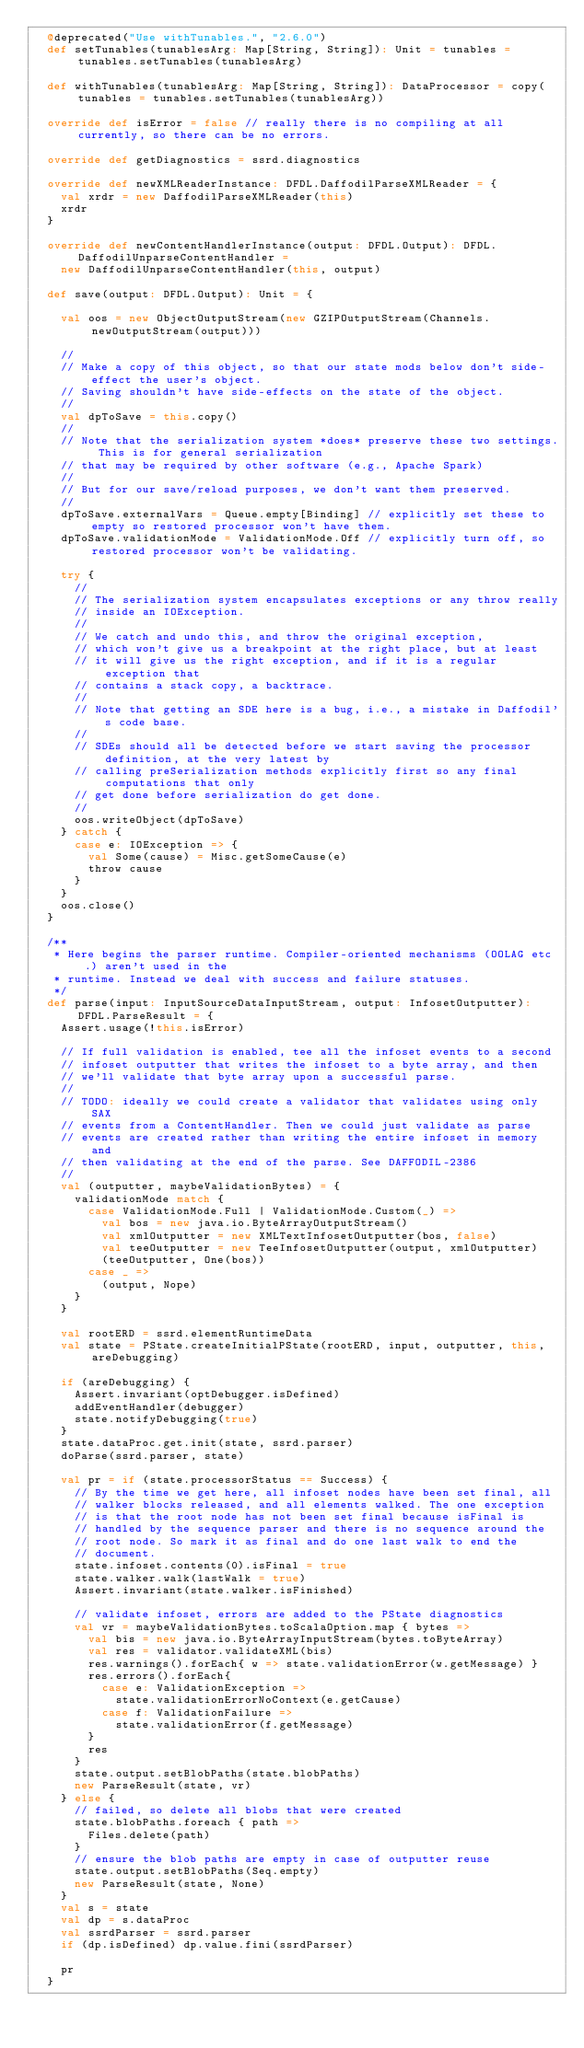Convert code to text. <code><loc_0><loc_0><loc_500><loc_500><_Scala_>  @deprecated("Use withTunables.", "2.6.0")
  def setTunables(tunablesArg: Map[String, String]): Unit = tunables = tunables.setTunables(tunablesArg)

  def withTunables(tunablesArg: Map[String, String]): DataProcessor = copy(tunables = tunables.setTunables(tunablesArg))

  override def isError = false // really there is no compiling at all currently, so there can be no errors.

  override def getDiagnostics = ssrd.diagnostics

  override def newXMLReaderInstance: DFDL.DaffodilParseXMLReader = {
    val xrdr = new DaffodilParseXMLReader(this)
    xrdr
  }

  override def newContentHandlerInstance(output: DFDL.Output): DFDL.DaffodilUnparseContentHandler =
    new DaffodilUnparseContentHandler(this, output)

  def save(output: DFDL.Output): Unit = {

    val oos = new ObjectOutputStream(new GZIPOutputStream(Channels.newOutputStream(output)))

    //
    // Make a copy of this object, so that our state mods below don't side-effect the user's object.
    // Saving shouldn't have side-effects on the state of the object.
    //
    val dpToSave = this.copy()
    //
    // Note that the serialization system *does* preserve these two settings. This is for general serialization
    // that may be required by other software (e.g., Apache Spark)
    //
    // But for our save/reload purposes, we don't want them preserved.
    //
    dpToSave.externalVars = Queue.empty[Binding] // explicitly set these to empty so restored processor won't have them.
    dpToSave.validationMode = ValidationMode.Off // explicitly turn off, so restored processor won't be validating.

    try {
      //
      // The serialization system encapsulates exceptions or any throw really
      // inside an IOException.
      //
      // We catch and undo this, and throw the original exception,
      // which won't give us a breakpoint at the right place, but at least
      // it will give us the right exception, and if it is a regular exception that
      // contains a stack copy, a backtrace.
      //
      // Note that getting an SDE here is a bug, i.e., a mistake in Daffodil's code base.
      //
      // SDEs should all be detected before we start saving the processor definition, at the very latest by
      // calling preSerialization methods explicitly first so any final computations that only
      // get done before serialization do get done.
      //
      oos.writeObject(dpToSave)
    } catch {
      case e: IOException => {
        val Some(cause) = Misc.getSomeCause(e)
        throw cause
      }
    }
    oos.close()
  }

  /**
   * Here begins the parser runtime. Compiler-oriented mechanisms (OOLAG etc.) aren't used in the
   * runtime. Instead we deal with success and failure statuses.
   */
  def parse(input: InputSourceDataInputStream, output: InfosetOutputter): DFDL.ParseResult = {
    Assert.usage(!this.isError)

    // If full validation is enabled, tee all the infoset events to a second
    // infoset outputter that writes the infoset to a byte array, and then
    // we'll validate that byte array upon a successful parse.
    //
    // TODO: ideally we could create a validator that validates using only SAX
    // events from a ContentHandler. Then we could just validate as parse
    // events are created rather than writing the entire infoset in memory and
    // then validating at the end of the parse. See DAFFODIL-2386
    //
    val (outputter, maybeValidationBytes) = {
      validationMode match {
        case ValidationMode.Full | ValidationMode.Custom(_) =>
          val bos = new java.io.ByteArrayOutputStream()
          val xmlOutputter = new XMLTextInfosetOutputter(bos, false)
          val teeOutputter = new TeeInfosetOutputter(output, xmlOutputter)
          (teeOutputter, One(bos))
        case _ =>
          (output, Nope)
      }
    }

    val rootERD = ssrd.elementRuntimeData
    val state = PState.createInitialPState(rootERD, input, outputter, this, areDebugging)

    if (areDebugging) {
      Assert.invariant(optDebugger.isDefined)
      addEventHandler(debugger)
      state.notifyDebugging(true)
    }
    state.dataProc.get.init(state, ssrd.parser)
    doParse(ssrd.parser, state)

    val pr = if (state.processorStatus == Success) {
      // By the time we get here, all infoset nodes have been set final, all
      // walker blocks released, and all elements walked. The one exception
      // is that the root node has not been set final because isFinal is
      // handled by the sequence parser and there is no sequence around the
      // root node. So mark it as final and do one last walk to end the
      // document.
      state.infoset.contents(0).isFinal = true
      state.walker.walk(lastWalk = true)
      Assert.invariant(state.walker.isFinished)

      // validate infoset, errors are added to the PState diagnostics
      val vr = maybeValidationBytes.toScalaOption.map { bytes =>
        val bis = new java.io.ByteArrayInputStream(bytes.toByteArray)
        val res = validator.validateXML(bis)
        res.warnings().forEach{ w => state.validationError(w.getMessage) }
        res.errors().forEach{
          case e: ValidationException =>
            state.validationErrorNoContext(e.getCause)
          case f: ValidationFailure =>
            state.validationError(f.getMessage)
        }
        res
      }
      state.output.setBlobPaths(state.blobPaths)
      new ParseResult(state, vr)
    } else {
      // failed, so delete all blobs that were created
      state.blobPaths.foreach { path =>
        Files.delete(path)
      }
      // ensure the blob paths are empty in case of outputter reuse
      state.output.setBlobPaths(Seq.empty)
      new ParseResult(state, None)
    }
    val s = state
    val dp = s.dataProc
    val ssrdParser = ssrd.parser
    if (dp.isDefined) dp.value.fini(ssrdParser)

    pr
  }
</code> 